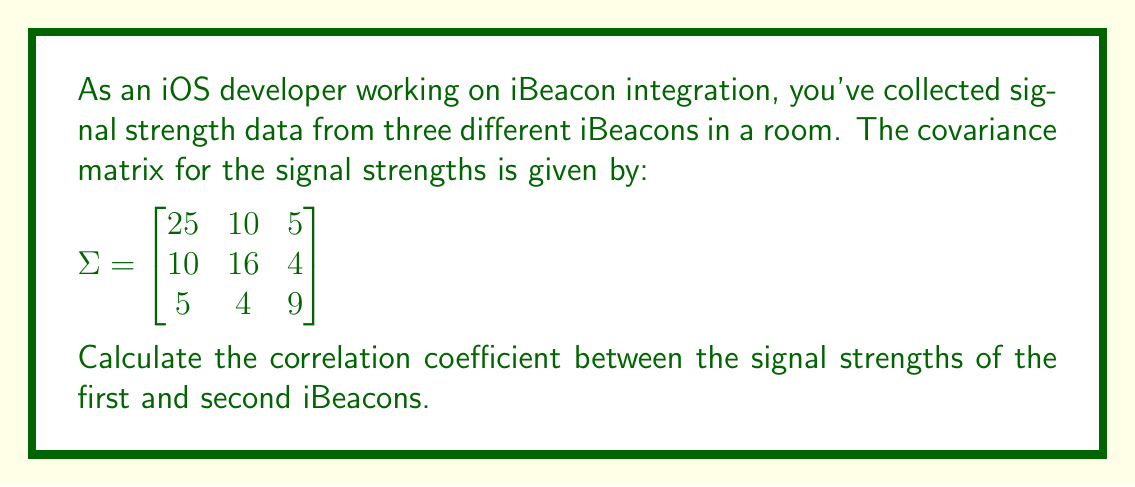Help me with this question. To find the correlation coefficient between the signal strengths of the first and second iBeacons, we'll follow these steps:

1. Recall the formula for the correlation coefficient:

   $$\rho_{12} = \frac{\sigma_{12}}{\sqrt{\sigma_{11}\sigma_{22}}}$$

   where $\sigma_{12}$ is the covariance between variables 1 and 2, and $\sigma_{11}$ and $\sigma_{22}$ are the variances of variables 1 and 2 respectively.

2. From the given covariance matrix:
   - $\sigma_{11} = 25$ (variance of first iBeacon's signal strength)
   - $\sigma_{22} = 16$ (variance of second iBeacon's signal strength)
   - $\sigma_{12} = 10$ (covariance between first and second iBeacon's signal strengths)

3. Substitute these values into the correlation coefficient formula:

   $$\rho_{12} = \frac{10}{\sqrt{25 \cdot 16}}$$

4. Simplify:
   $$\rho_{12} = \frac{10}{\sqrt{400}} = \frac{10}{20} = 0.5$$

The correlation coefficient between the signal strengths of the first and second iBeacons is 0.5.
Answer: 0.5 